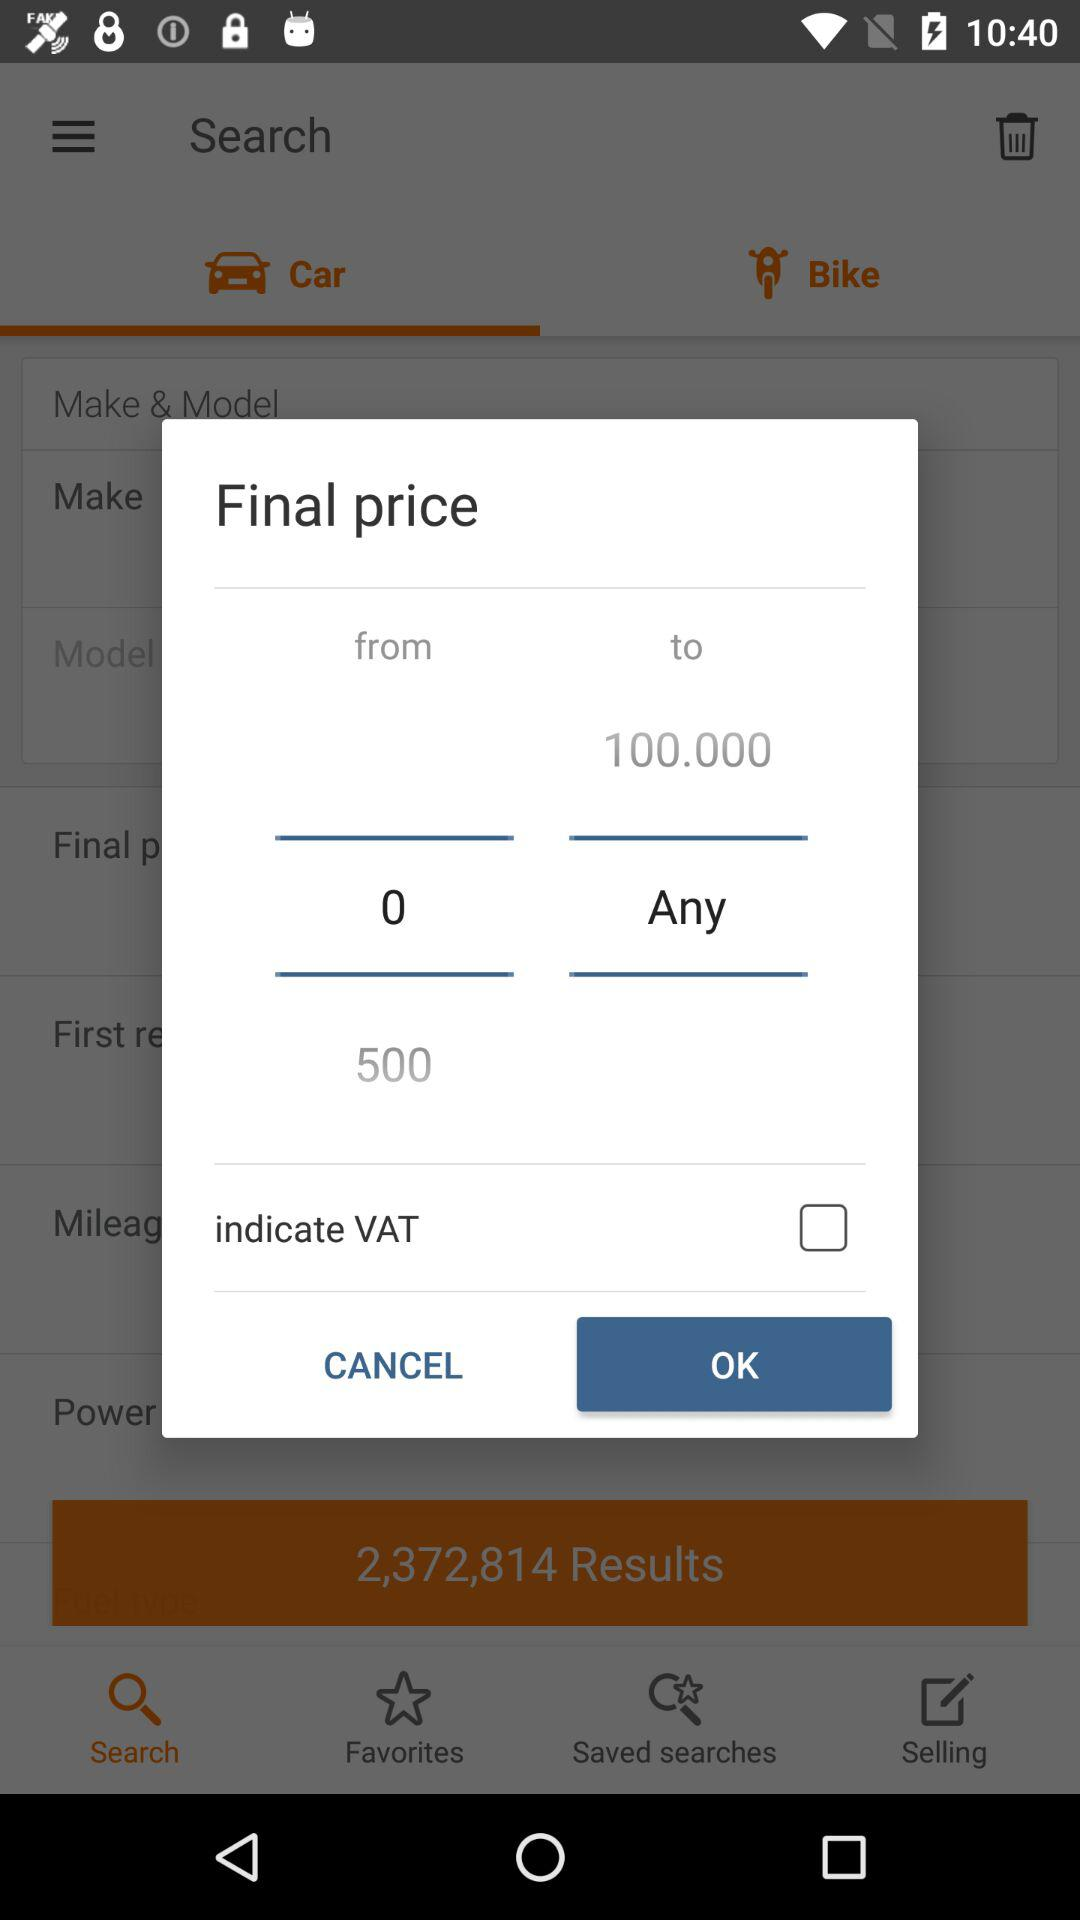How many total results are shown? There are 2,372,814 results shown. 